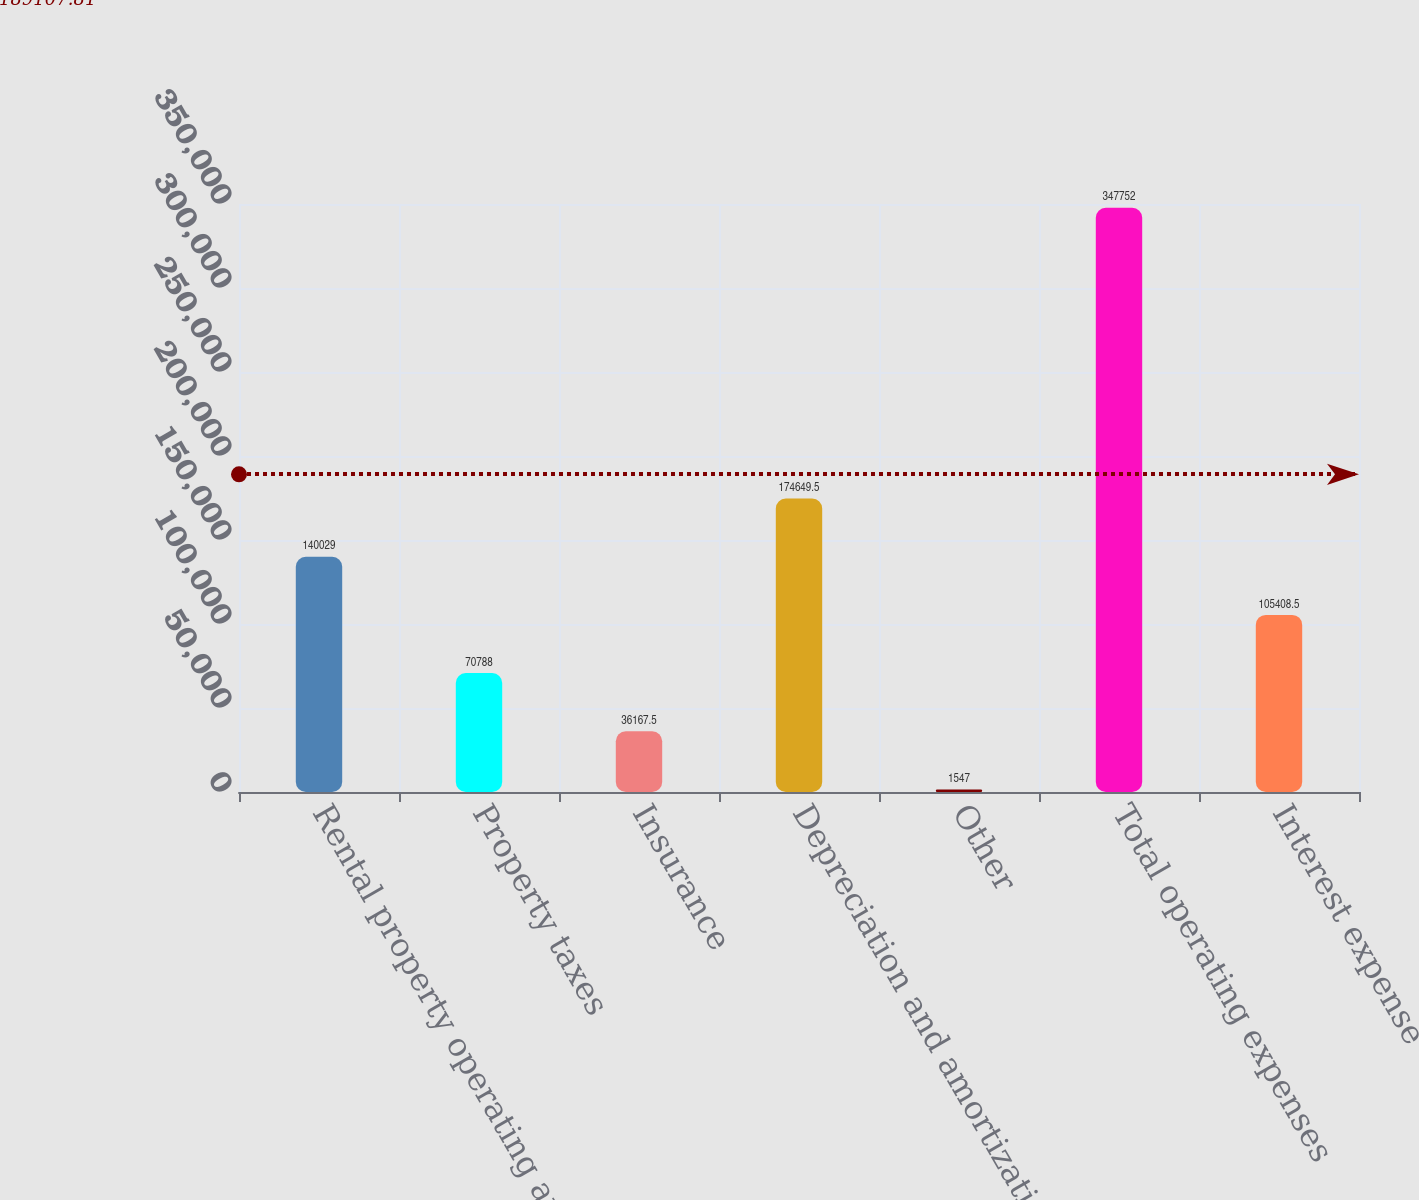<chart> <loc_0><loc_0><loc_500><loc_500><bar_chart><fcel>Rental property operating and<fcel>Property taxes<fcel>Insurance<fcel>Depreciation and amortization<fcel>Other<fcel>Total operating expenses<fcel>Interest expense<nl><fcel>140029<fcel>70788<fcel>36167.5<fcel>174650<fcel>1547<fcel>347752<fcel>105408<nl></chart> 